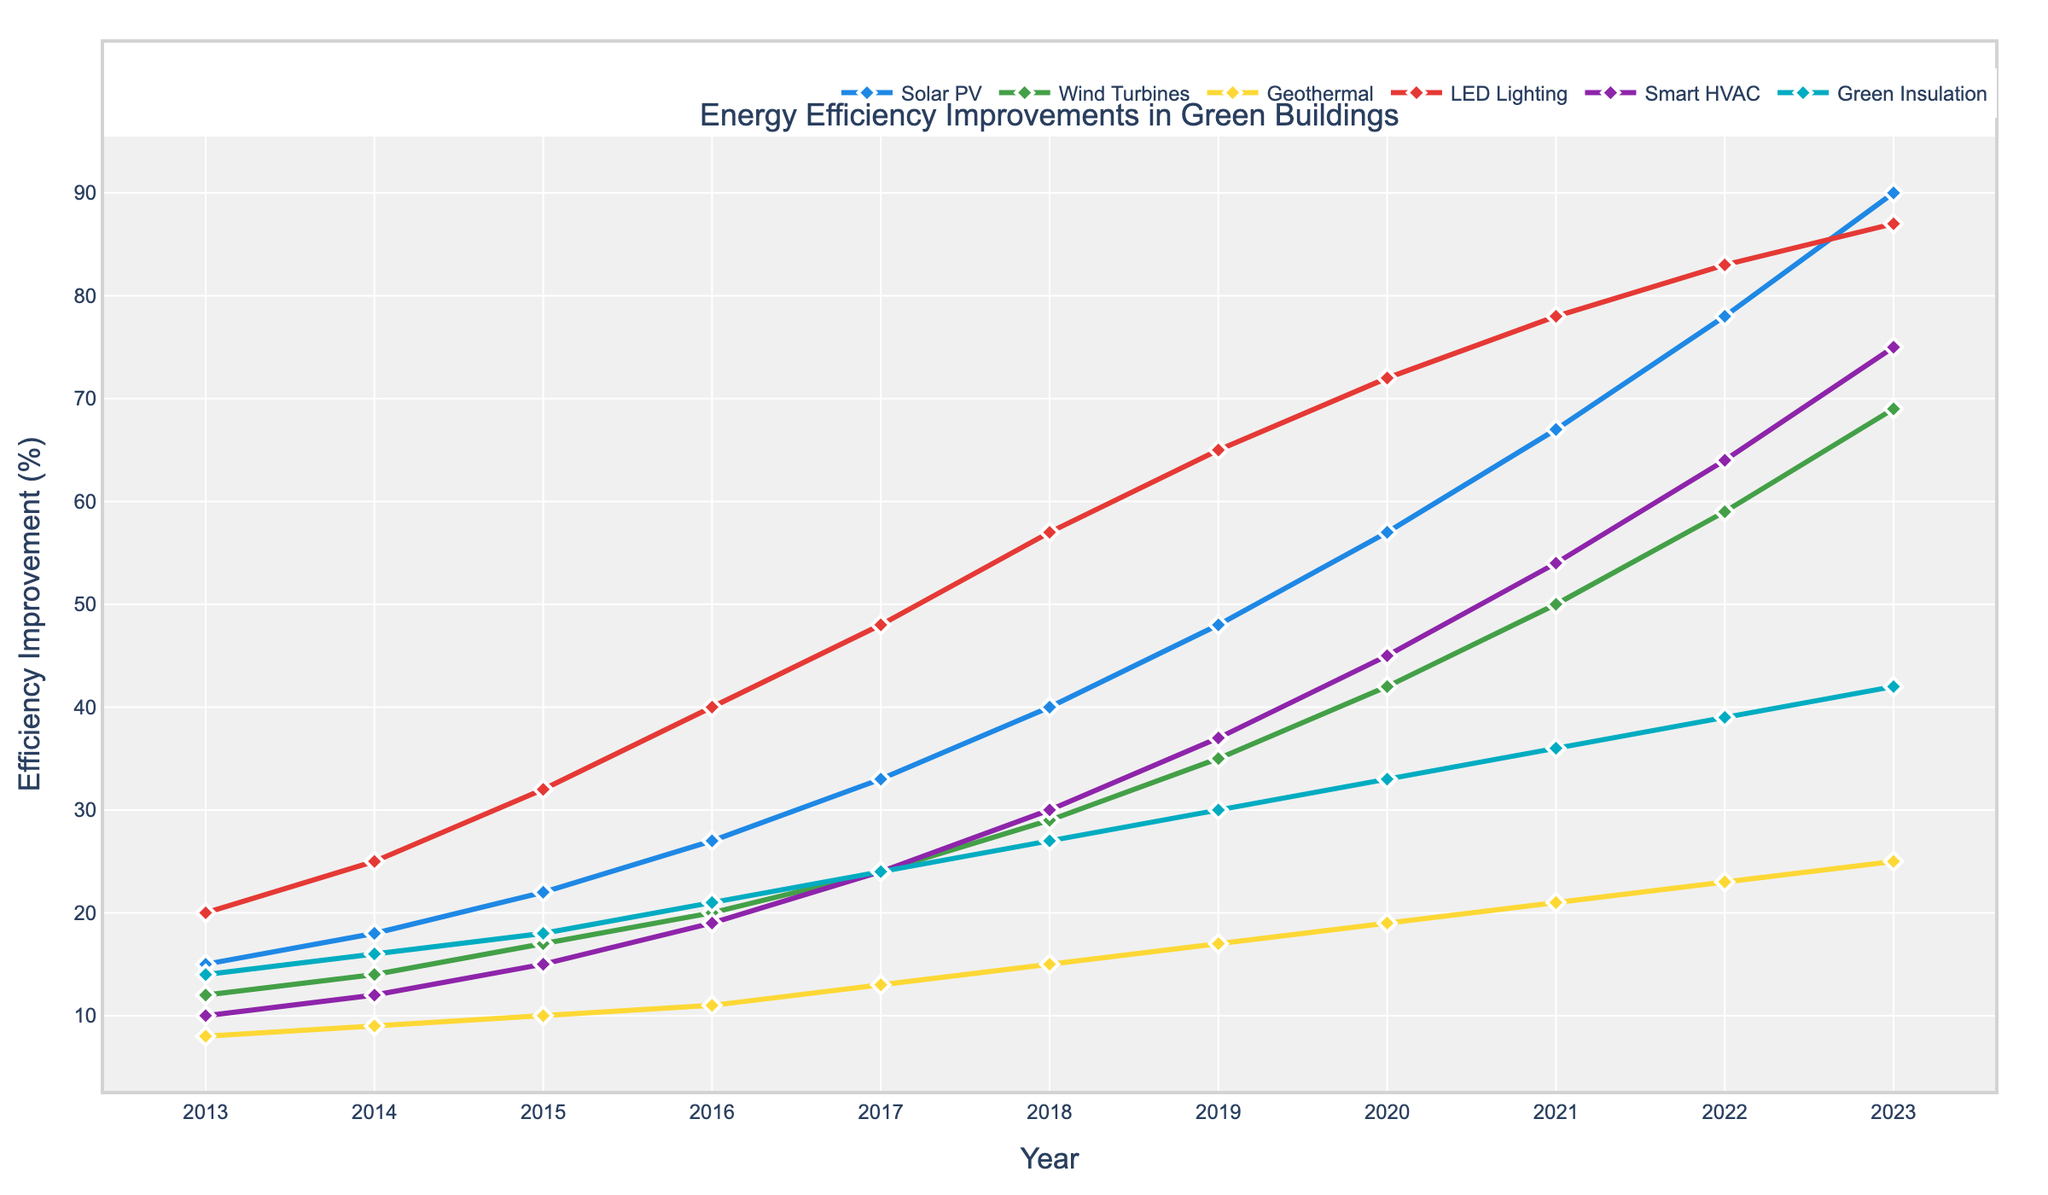what is the overall trend for Solar PV efficiency improvements from 2013 to 2023? By observing the line representing Solar PV, it is clear that the chart shows an increasing trend, starting from 15% in 2013 and reaching 90% in 2023.
Answer: Increasing Which technology type had the highest efficiency improvement in 2023? By looking at the endpoints of each line for the year 2023, the number indicated for Solar PV is 90%, which is the highest among all the technologies.
Answer: Solar PV How do the efficiency improvements of LED Lighting and Wind Turbines compare in 2020? The chart shows that in 2020, LED Lighting had an efficiency improvement of 72%, while Wind Turbines had 42%. LED Lighting improvements were much greater than Wind Turbines.
Answer: LED Lighting > Wind Turbines What was the percentage increase in efficiency improvement for Smart HVAC from 2015 to 2023? In 2015, Smart HVAC had an improvement of 15%, and by 2023, it increased to 75%. The increase is 75% - 15% = 60%.
Answer: 60% Which year did Green Insulation's efficiency improvement reach 27%, and how does this compare visually with other technologies in the same year? Green Insulation reached 27% in 2018. Visually, in that year, efficiency improvements for other technologies were Solar PV (40%), Wind Turbines (29%), Geothermal (15%), LED Lighting (57%), and Smart HVAC (30%). This makes Green Insulation the third lowest, higher than Geothermal and close to Smart HVAC.
Answer: 2018, third lowest Between which years did the efficiency improvements of Geothermal remain in single digits, and what could this indicate? The efficiency improvements for Geothermal remained in single digits up until 2014, as it was 9%. This might indicate slower initial development or adoption of Geothermal technology compared to other years.
Answer: Until 2014 How does the growth rate of the efficiency improvement of Solar PV compare to that of Wind Turbines from 2013 to 2023? Use approximations if necessary. Solar PV increased from 15% in 2013 to 90% in 2023, a total increase of 75%. Wind Turbines increased from 12% in 2013 to 69% in 2023, a total increase of 57%. The growth rate for Solar PV has been faster compared to Wind Turbines.
Answer: Solar PV > Wind Turbines What visual attribute stands out about Smart HVAC improvements from 2016 onward? From 2016 onward, the Smart HVAC line becomes steeper and consistently increases, showing significant year-on-year improvements, particularly from 2018 to 2023.
Answer: Steeper increase In which year did all six technologies show a marked improvement from their previous years, and how can you visualize this? In 2017, all six technologies had a marked improvement compared to 2016, as indicated by the noticeable upward slopes in the lines for each technology.
Answer: 2017 